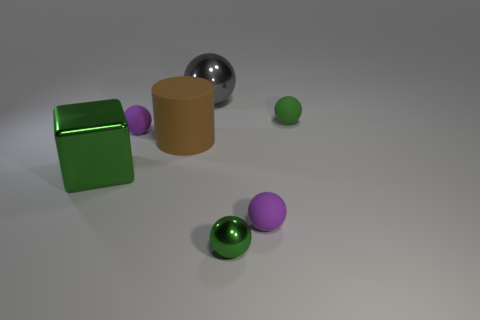What number of things are rubber things that are on the left side of the large matte cylinder or objects to the right of the big gray shiny thing?
Offer a very short reply. 4. What number of big gray shiny spheres are left of the tiny purple rubber ball that is right of the matte cylinder?
Ensure brevity in your answer.  1. Do the large metal thing left of the brown cylinder and the small green object that is in front of the green rubber sphere have the same shape?
Keep it short and to the point. No. What shape is the rubber object that is the same color as the cube?
Give a very brief answer. Sphere. Is there a yellow object that has the same material as the big gray ball?
Provide a short and direct response. No. What number of metal objects are tiny yellow cubes or brown objects?
Your response must be concise. 0. What is the shape of the object that is on the right side of the matte object in front of the rubber cylinder?
Provide a succinct answer. Sphere. Are there fewer small green balls in front of the large brown thing than tiny green metallic balls?
Give a very brief answer. No. The big green metal object has what shape?
Provide a short and direct response. Cube. What is the size of the green shiny object that is behind the tiny metal sphere?
Your answer should be very brief. Large. 